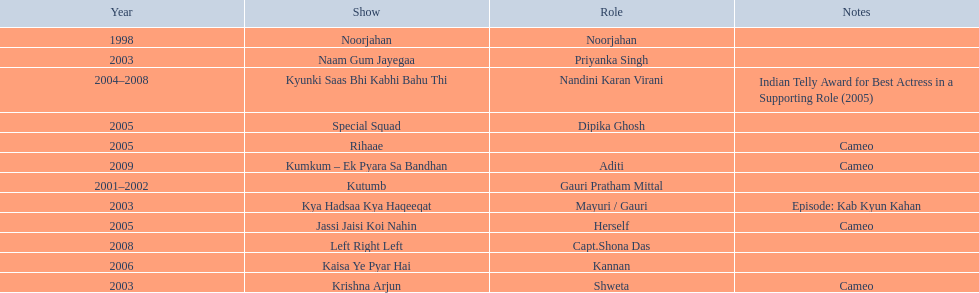What are all of the shows? Noorjahan, Kutumb, Krishna Arjun, Naam Gum Jayegaa, Kya Hadsaa Kya Haqeeqat, Kyunki Saas Bhi Kabhi Bahu Thi, Rihaae, Jassi Jaisi Koi Nahin, Special Squad, Kaisa Ye Pyar Hai, Left Right Left, Kumkum – Ek Pyara Sa Bandhan. When did they premiere? 1998, 2001–2002, 2003, 2003, 2003, 2004–2008, 2005, 2005, 2005, 2006, 2008, 2009. What notes are there for the shows from 2005? Cameo, Cameo. Along with rihaee, what is the other show gauri had a cameo role in? Jassi Jaisi Koi Nahin. 